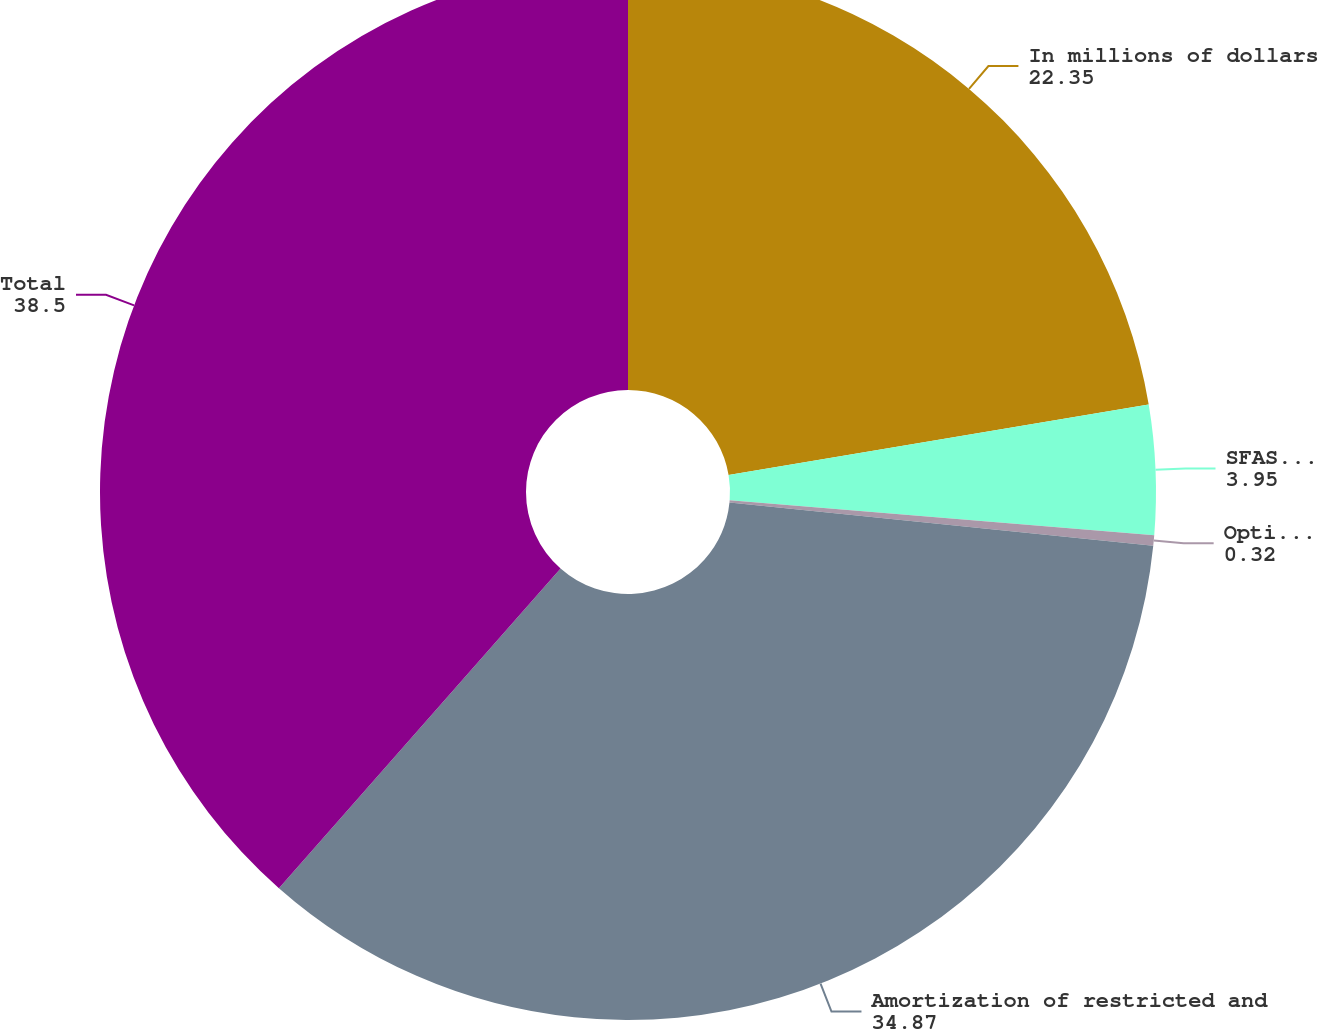<chart> <loc_0><loc_0><loc_500><loc_500><pie_chart><fcel>In millions of dollars<fcel>SFAS 123(R) charges for<fcel>Option expense<fcel>Amortization of restricted and<fcel>Total<nl><fcel>22.35%<fcel>3.95%<fcel>0.32%<fcel>34.87%<fcel>38.5%<nl></chart> 